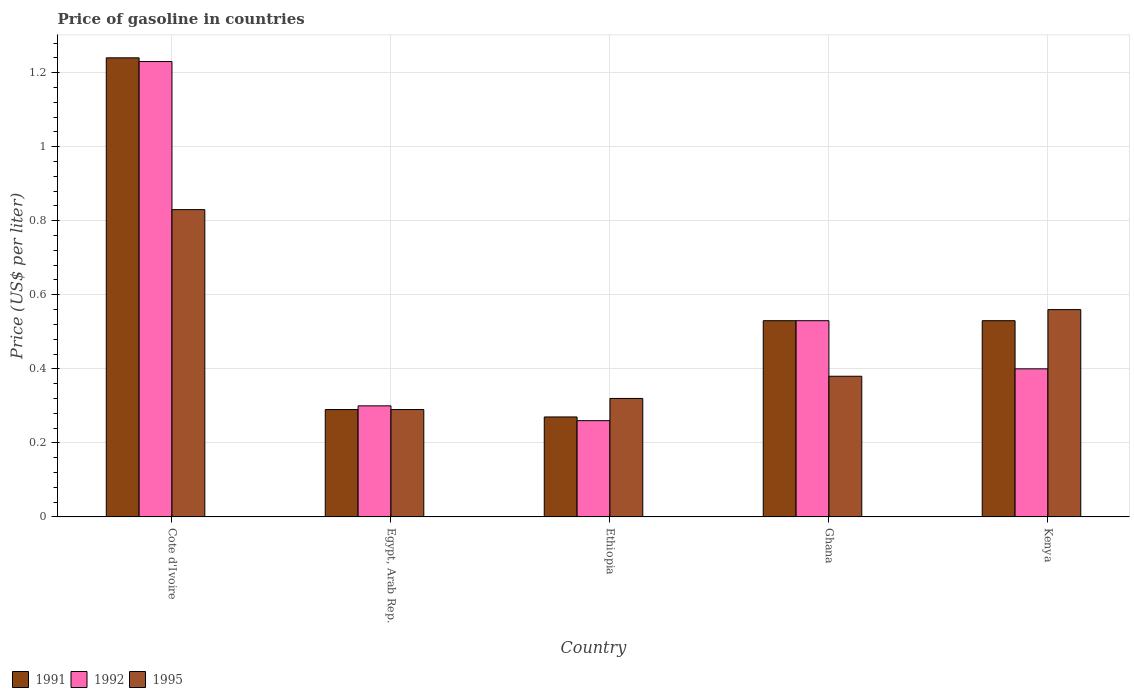How many groups of bars are there?
Provide a short and direct response. 5. Are the number of bars per tick equal to the number of legend labels?
Provide a succinct answer. Yes. How many bars are there on the 1st tick from the right?
Offer a very short reply. 3. What is the label of the 1st group of bars from the left?
Ensure brevity in your answer.  Cote d'Ivoire. In how many cases, is the number of bars for a given country not equal to the number of legend labels?
Ensure brevity in your answer.  0. What is the price of gasoline in 1995 in Ghana?
Offer a very short reply. 0.38. Across all countries, what is the maximum price of gasoline in 1992?
Your answer should be very brief. 1.23. Across all countries, what is the minimum price of gasoline in 1992?
Offer a very short reply. 0.26. In which country was the price of gasoline in 1995 maximum?
Your answer should be very brief. Cote d'Ivoire. In which country was the price of gasoline in 1992 minimum?
Keep it short and to the point. Ethiopia. What is the total price of gasoline in 1992 in the graph?
Offer a very short reply. 2.72. What is the difference between the price of gasoline in 1995 in Cote d'Ivoire and that in Kenya?
Offer a terse response. 0.27. What is the difference between the price of gasoline in 1991 in Ghana and the price of gasoline in 1995 in Ethiopia?
Your answer should be very brief. 0.21. What is the average price of gasoline in 1991 per country?
Your answer should be compact. 0.57. What is the difference between the price of gasoline of/in 1991 and price of gasoline of/in 1995 in Cote d'Ivoire?
Keep it short and to the point. 0.41. What is the ratio of the price of gasoline in 1991 in Ethiopia to that in Kenya?
Give a very brief answer. 0.51. Is the difference between the price of gasoline in 1991 in Ghana and Kenya greater than the difference between the price of gasoline in 1995 in Ghana and Kenya?
Keep it short and to the point. Yes. What is the difference between the highest and the lowest price of gasoline in 1991?
Your response must be concise. 0.97. In how many countries, is the price of gasoline in 1992 greater than the average price of gasoline in 1992 taken over all countries?
Your response must be concise. 1. How many countries are there in the graph?
Your response must be concise. 5. What is the difference between two consecutive major ticks on the Y-axis?
Your answer should be very brief. 0.2. Are the values on the major ticks of Y-axis written in scientific E-notation?
Ensure brevity in your answer.  No. Does the graph contain any zero values?
Make the answer very short. No. How many legend labels are there?
Your answer should be very brief. 3. What is the title of the graph?
Give a very brief answer. Price of gasoline in countries. Does "1982" appear as one of the legend labels in the graph?
Give a very brief answer. No. What is the label or title of the Y-axis?
Provide a succinct answer. Price (US$ per liter). What is the Price (US$ per liter) in 1991 in Cote d'Ivoire?
Offer a terse response. 1.24. What is the Price (US$ per liter) of 1992 in Cote d'Ivoire?
Give a very brief answer. 1.23. What is the Price (US$ per liter) in 1995 in Cote d'Ivoire?
Make the answer very short. 0.83. What is the Price (US$ per liter) of 1991 in Egypt, Arab Rep.?
Provide a succinct answer. 0.29. What is the Price (US$ per liter) in 1995 in Egypt, Arab Rep.?
Your response must be concise. 0.29. What is the Price (US$ per liter) in 1991 in Ethiopia?
Give a very brief answer. 0.27. What is the Price (US$ per liter) of 1992 in Ethiopia?
Offer a very short reply. 0.26. What is the Price (US$ per liter) of 1995 in Ethiopia?
Give a very brief answer. 0.32. What is the Price (US$ per liter) of 1991 in Ghana?
Offer a very short reply. 0.53. What is the Price (US$ per liter) of 1992 in Ghana?
Your answer should be very brief. 0.53. What is the Price (US$ per liter) in 1995 in Ghana?
Your answer should be compact. 0.38. What is the Price (US$ per liter) of 1991 in Kenya?
Your answer should be very brief. 0.53. What is the Price (US$ per liter) of 1992 in Kenya?
Provide a short and direct response. 0.4. What is the Price (US$ per liter) in 1995 in Kenya?
Your answer should be very brief. 0.56. Across all countries, what is the maximum Price (US$ per liter) in 1991?
Your answer should be very brief. 1.24. Across all countries, what is the maximum Price (US$ per liter) of 1992?
Give a very brief answer. 1.23. Across all countries, what is the maximum Price (US$ per liter) in 1995?
Ensure brevity in your answer.  0.83. Across all countries, what is the minimum Price (US$ per liter) in 1991?
Your response must be concise. 0.27. Across all countries, what is the minimum Price (US$ per liter) in 1992?
Provide a succinct answer. 0.26. Across all countries, what is the minimum Price (US$ per liter) in 1995?
Give a very brief answer. 0.29. What is the total Price (US$ per liter) in 1991 in the graph?
Provide a short and direct response. 2.86. What is the total Price (US$ per liter) in 1992 in the graph?
Provide a short and direct response. 2.72. What is the total Price (US$ per liter) of 1995 in the graph?
Offer a very short reply. 2.38. What is the difference between the Price (US$ per liter) of 1992 in Cote d'Ivoire and that in Egypt, Arab Rep.?
Your answer should be very brief. 0.93. What is the difference between the Price (US$ per liter) in 1995 in Cote d'Ivoire and that in Egypt, Arab Rep.?
Provide a succinct answer. 0.54. What is the difference between the Price (US$ per liter) of 1992 in Cote d'Ivoire and that in Ethiopia?
Offer a very short reply. 0.97. What is the difference between the Price (US$ per liter) of 1995 in Cote d'Ivoire and that in Ethiopia?
Your response must be concise. 0.51. What is the difference between the Price (US$ per liter) in 1991 in Cote d'Ivoire and that in Ghana?
Your answer should be compact. 0.71. What is the difference between the Price (US$ per liter) of 1995 in Cote d'Ivoire and that in Ghana?
Offer a terse response. 0.45. What is the difference between the Price (US$ per liter) of 1991 in Cote d'Ivoire and that in Kenya?
Your answer should be compact. 0.71. What is the difference between the Price (US$ per liter) of 1992 in Cote d'Ivoire and that in Kenya?
Offer a very short reply. 0.83. What is the difference between the Price (US$ per liter) of 1995 in Cote d'Ivoire and that in Kenya?
Keep it short and to the point. 0.27. What is the difference between the Price (US$ per liter) in 1991 in Egypt, Arab Rep. and that in Ethiopia?
Offer a terse response. 0.02. What is the difference between the Price (US$ per liter) of 1995 in Egypt, Arab Rep. and that in Ethiopia?
Provide a succinct answer. -0.03. What is the difference between the Price (US$ per liter) of 1991 in Egypt, Arab Rep. and that in Ghana?
Give a very brief answer. -0.24. What is the difference between the Price (US$ per liter) in 1992 in Egypt, Arab Rep. and that in Ghana?
Your response must be concise. -0.23. What is the difference between the Price (US$ per liter) in 1995 in Egypt, Arab Rep. and that in Ghana?
Ensure brevity in your answer.  -0.09. What is the difference between the Price (US$ per liter) of 1991 in Egypt, Arab Rep. and that in Kenya?
Make the answer very short. -0.24. What is the difference between the Price (US$ per liter) in 1995 in Egypt, Arab Rep. and that in Kenya?
Offer a very short reply. -0.27. What is the difference between the Price (US$ per liter) in 1991 in Ethiopia and that in Ghana?
Keep it short and to the point. -0.26. What is the difference between the Price (US$ per liter) in 1992 in Ethiopia and that in Ghana?
Your response must be concise. -0.27. What is the difference between the Price (US$ per liter) in 1995 in Ethiopia and that in Ghana?
Make the answer very short. -0.06. What is the difference between the Price (US$ per liter) in 1991 in Ethiopia and that in Kenya?
Offer a very short reply. -0.26. What is the difference between the Price (US$ per liter) in 1992 in Ethiopia and that in Kenya?
Your answer should be compact. -0.14. What is the difference between the Price (US$ per liter) in 1995 in Ethiopia and that in Kenya?
Keep it short and to the point. -0.24. What is the difference between the Price (US$ per liter) of 1991 in Ghana and that in Kenya?
Keep it short and to the point. 0. What is the difference between the Price (US$ per liter) in 1992 in Ghana and that in Kenya?
Keep it short and to the point. 0.13. What is the difference between the Price (US$ per liter) of 1995 in Ghana and that in Kenya?
Provide a succinct answer. -0.18. What is the difference between the Price (US$ per liter) of 1991 in Cote d'Ivoire and the Price (US$ per liter) of 1995 in Egypt, Arab Rep.?
Give a very brief answer. 0.95. What is the difference between the Price (US$ per liter) of 1992 in Cote d'Ivoire and the Price (US$ per liter) of 1995 in Egypt, Arab Rep.?
Keep it short and to the point. 0.94. What is the difference between the Price (US$ per liter) of 1991 in Cote d'Ivoire and the Price (US$ per liter) of 1992 in Ethiopia?
Your answer should be very brief. 0.98. What is the difference between the Price (US$ per liter) of 1991 in Cote d'Ivoire and the Price (US$ per liter) of 1995 in Ethiopia?
Provide a succinct answer. 0.92. What is the difference between the Price (US$ per liter) in 1992 in Cote d'Ivoire and the Price (US$ per liter) in 1995 in Ethiopia?
Make the answer very short. 0.91. What is the difference between the Price (US$ per liter) in 1991 in Cote d'Ivoire and the Price (US$ per liter) in 1992 in Ghana?
Your response must be concise. 0.71. What is the difference between the Price (US$ per liter) in 1991 in Cote d'Ivoire and the Price (US$ per liter) in 1995 in Ghana?
Your response must be concise. 0.86. What is the difference between the Price (US$ per liter) of 1992 in Cote d'Ivoire and the Price (US$ per liter) of 1995 in Ghana?
Make the answer very short. 0.85. What is the difference between the Price (US$ per liter) of 1991 in Cote d'Ivoire and the Price (US$ per liter) of 1992 in Kenya?
Your answer should be compact. 0.84. What is the difference between the Price (US$ per liter) in 1991 in Cote d'Ivoire and the Price (US$ per liter) in 1995 in Kenya?
Provide a succinct answer. 0.68. What is the difference between the Price (US$ per liter) of 1992 in Cote d'Ivoire and the Price (US$ per liter) of 1995 in Kenya?
Your response must be concise. 0.67. What is the difference between the Price (US$ per liter) in 1991 in Egypt, Arab Rep. and the Price (US$ per liter) in 1992 in Ethiopia?
Keep it short and to the point. 0.03. What is the difference between the Price (US$ per liter) in 1991 in Egypt, Arab Rep. and the Price (US$ per liter) in 1995 in Ethiopia?
Give a very brief answer. -0.03. What is the difference between the Price (US$ per liter) of 1992 in Egypt, Arab Rep. and the Price (US$ per liter) of 1995 in Ethiopia?
Provide a short and direct response. -0.02. What is the difference between the Price (US$ per liter) in 1991 in Egypt, Arab Rep. and the Price (US$ per liter) in 1992 in Ghana?
Provide a succinct answer. -0.24. What is the difference between the Price (US$ per liter) in 1991 in Egypt, Arab Rep. and the Price (US$ per liter) in 1995 in Ghana?
Make the answer very short. -0.09. What is the difference between the Price (US$ per liter) in 1992 in Egypt, Arab Rep. and the Price (US$ per liter) in 1995 in Ghana?
Make the answer very short. -0.08. What is the difference between the Price (US$ per liter) of 1991 in Egypt, Arab Rep. and the Price (US$ per liter) of 1992 in Kenya?
Provide a succinct answer. -0.11. What is the difference between the Price (US$ per liter) of 1991 in Egypt, Arab Rep. and the Price (US$ per liter) of 1995 in Kenya?
Provide a succinct answer. -0.27. What is the difference between the Price (US$ per liter) of 1992 in Egypt, Arab Rep. and the Price (US$ per liter) of 1995 in Kenya?
Your answer should be very brief. -0.26. What is the difference between the Price (US$ per liter) in 1991 in Ethiopia and the Price (US$ per liter) in 1992 in Ghana?
Keep it short and to the point. -0.26. What is the difference between the Price (US$ per liter) in 1991 in Ethiopia and the Price (US$ per liter) in 1995 in Ghana?
Offer a terse response. -0.11. What is the difference between the Price (US$ per liter) in 1992 in Ethiopia and the Price (US$ per liter) in 1995 in Ghana?
Provide a short and direct response. -0.12. What is the difference between the Price (US$ per liter) of 1991 in Ethiopia and the Price (US$ per liter) of 1992 in Kenya?
Your answer should be compact. -0.13. What is the difference between the Price (US$ per liter) of 1991 in Ethiopia and the Price (US$ per liter) of 1995 in Kenya?
Provide a short and direct response. -0.29. What is the difference between the Price (US$ per liter) in 1992 in Ethiopia and the Price (US$ per liter) in 1995 in Kenya?
Your answer should be compact. -0.3. What is the difference between the Price (US$ per liter) of 1991 in Ghana and the Price (US$ per liter) of 1992 in Kenya?
Keep it short and to the point. 0.13. What is the difference between the Price (US$ per liter) of 1991 in Ghana and the Price (US$ per liter) of 1995 in Kenya?
Provide a short and direct response. -0.03. What is the difference between the Price (US$ per liter) of 1992 in Ghana and the Price (US$ per liter) of 1995 in Kenya?
Offer a very short reply. -0.03. What is the average Price (US$ per liter) of 1991 per country?
Ensure brevity in your answer.  0.57. What is the average Price (US$ per liter) of 1992 per country?
Offer a very short reply. 0.54. What is the average Price (US$ per liter) of 1995 per country?
Your answer should be compact. 0.48. What is the difference between the Price (US$ per liter) of 1991 and Price (US$ per liter) of 1995 in Cote d'Ivoire?
Your answer should be compact. 0.41. What is the difference between the Price (US$ per liter) in 1992 and Price (US$ per liter) in 1995 in Cote d'Ivoire?
Provide a succinct answer. 0.4. What is the difference between the Price (US$ per liter) of 1991 and Price (US$ per liter) of 1992 in Egypt, Arab Rep.?
Your answer should be very brief. -0.01. What is the difference between the Price (US$ per liter) in 1992 and Price (US$ per liter) in 1995 in Egypt, Arab Rep.?
Your answer should be very brief. 0.01. What is the difference between the Price (US$ per liter) of 1991 and Price (US$ per liter) of 1992 in Ethiopia?
Keep it short and to the point. 0.01. What is the difference between the Price (US$ per liter) of 1992 and Price (US$ per liter) of 1995 in Ethiopia?
Keep it short and to the point. -0.06. What is the difference between the Price (US$ per liter) in 1991 and Price (US$ per liter) in 1992 in Ghana?
Keep it short and to the point. 0. What is the difference between the Price (US$ per liter) in 1992 and Price (US$ per liter) in 1995 in Ghana?
Your response must be concise. 0.15. What is the difference between the Price (US$ per liter) in 1991 and Price (US$ per liter) in 1992 in Kenya?
Offer a very short reply. 0.13. What is the difference between the Price (US$ per liter) in 1991 and Price (US$ per liter) in 1995 in Kenya?
Offer a terse response. -0.03. What is the difference between the Price (US$ per liter) of 1992 and Price (US$ per liter) of 1995 in Kenya?
Make the answer very short. -0.16. What is the ratio of the Price (US$ per liter) in 1991 in Cote d'Ivoire to that in Egypt, Arab Rep.?
Offer a very short reply. 4.28. What is the ratio of the Price (US$ per liter) in 1995 in Cote d'Ivoire to that in Egypt, Arab Rep.?
Give a very brief answer. 2.86. What is the ratio of the Price (US$ per liter) in 1991 in Cote d'Ivoire to that in Ethiopia?
Give a very brief answer. 4.59. What is the ratio of the Price (US$ per liter) in 1992 in Cote d'Ivoire to that in Ethiopia?
Your response must be concise. 4.73. What is the ratio of the Price (US$ per liter) in 1995 in Cote d'Ivoire to that in Ethiopia?
Give a very brief answer. 2.59. What is the ratio of the Price (US$ per liter) of 1991 in Cote d'Ivoire to that in Ghana?
Your response must be concise. 2.34. What is the ratio of the Price (US$ per liter) in 1992 in Cote d'Ivoire to that in Ghana?
Make the answer very short. 2.32. What is the ratio of the Price (US$ per liter) in 1995 in Cote d'Ivoire to that in Ghana?
Make the answer very short. 2.18. What is the ratio of the Price (US$ per liter) in 1991 in Cote d'Ivoire to that in Kenya?
Keep it short and to the point. 2.34. What is the ratio of the Price (US$ per liter) of 1992 in Cote d'Ivoire to that in Kenya?
Make the answer very short. 3.08. What is the ratio of the Price (US$ per liter) of 1995 in Cote d'Ivoire to that in Kenya?
Ensure brevity in your answer.  1.48. What is the ratio of the Price (US$ per liter) in 1991 in Egypt, Arab Rep. to that in Ethiopia?
Offer a terse response. 1.07. What is the ratio of the Price (US$ per liter) in 1992 in Egypt, Arab Rep. to that in Ethiopia?
Your response must be concise. 1.15. What is the ratio of the Price (US$ per liter) of 1995 in Egypt, Arab Rep. to that in Ethiopia?
Your answer should be very brief. 0.91. What is the ratio of the Price (US$ per liter) in 1991 in Egypt, Arab Rep. to that in Ghana?
Give a very brief answer. 0.55. What is the ratio of the Price (US$ per liter) of 1992 in Egypt, Arab Rep. to that in Ghana?
Ensure brevity in your answer.  0.57. What is the ratio of the Price (US$ per liter) of 1995 in Egypt, Arab Rep. to that in Ghana?
Give a very brief answer. 0.76. What is the ratio of the Price (US$ per liter) in 1991 in Egypt, Arab Rep. to that in Kenya?
Your answer should be compact. 0.55. What is the ratio of the Price (US$ per liter) in 1992 in Egypt, Arab Rep. to that in Kenya?
Make the answer very short. 0.75. What is the ratio of the Price (US$ per liter) in 1995 in Egypt, Arab Rep. to that in Kenya?
Offer a very short reply. 0.52. What is the ratio of the Price (US$ per liter) in 1991 in Ethiopia to that in Ghana?
Your response must be concise. 0.51. What is the ratio of the Price (US$ per liter) in 1992 in Ethiopia to that in Ghana?
Give a very brief answer. 0.49. What is the ratio of the Price (US$ per liter) of 1995 in Ethiopia to that in Ghana?
Your answer should be very brief. 0.84. What is the ratio of the Price (US$ per liter) in 1991 in Ethiopia to that in Kenya?
Your answer should be compact. 0.51. What is the ratio of the Price (US$ per liter) in 1992 in Ethiopia to that in Kenya?
Ensure brevity in your answer.  0.65. What is the ratio of the Price (US$ per liter) of 1992 in Ghana to that in Kenya?
Your answer should be compact. 1.32. What is the ratio of the Price (US$ per liter) of 1995 in Ghana to that in Kenya?
Ensure brevity in your answer.  0.68. What is the difference between the highest and the second highest Price (US$ per liter) in 1991?
Your answer should be very brief. 0.71. What is the difference between the highest and the second highest Price (US$ per liter) of 1995?
Give a very brief answer. 0.27. What is the difference between the highest and the lowest Price (US$ per liter) in 1992?
Make the answer very short. 0.97. What is the difference between the highest and the lowest Price (US$ per liter) in 1995?
Offer a terse response. 0.54. 